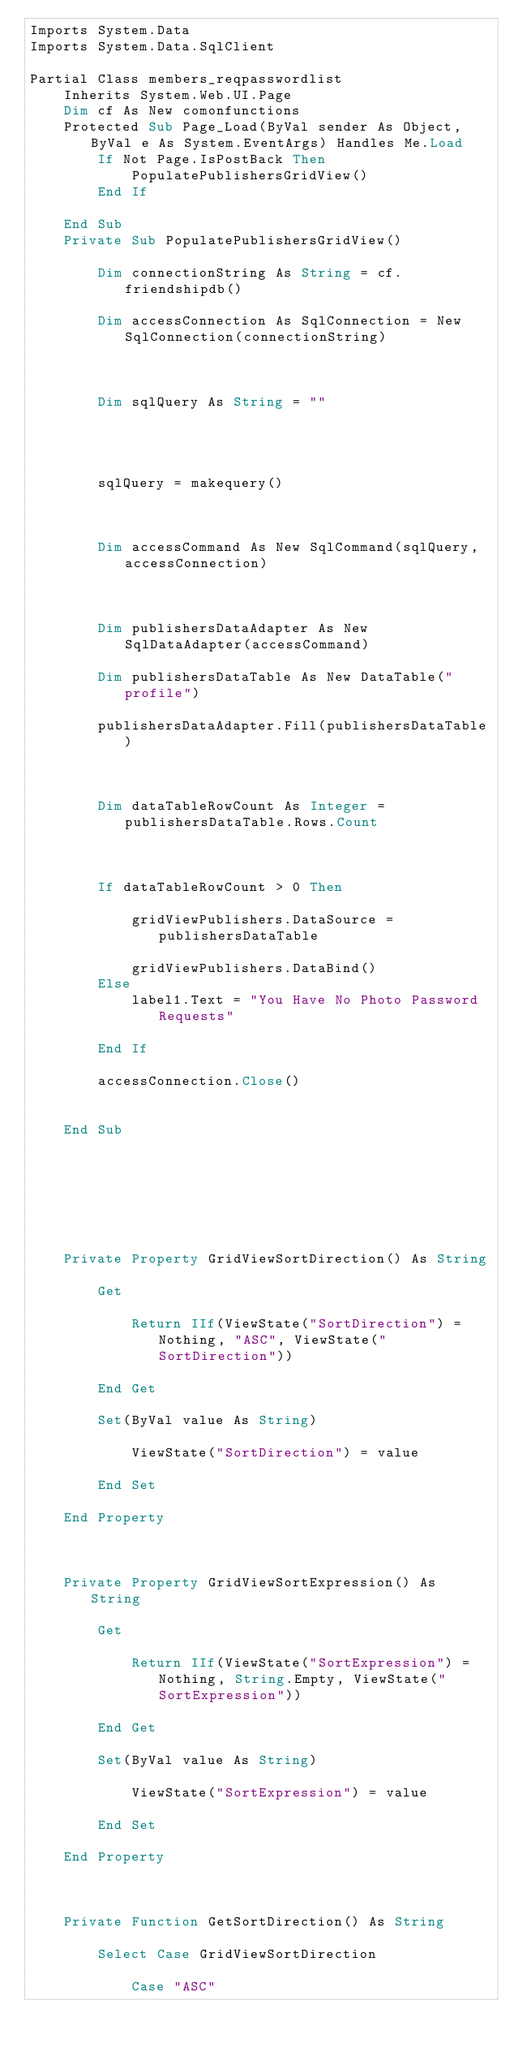<code> <loc_0><loc_0><loc_500><loc_500><_VisualBasic_>Imports System.Data
Imports System.Data.SqlClient

Partial Class members_reqpasswordlist
    Inherits System.Web.UI.Page
    Dim cf As New comonfunctions
    Protected Sub Page_Load(ByVal sender As Object, ByVal e As System.EventArgs) Handles Me.Load
        If Not Page.IsPostBack Then
            PopulatePublishersGridView()
        End If

    End Sub
    Private Sub PopulatePublishersGridView()

        Dim connectionString As String = cf.friendshipdb()

        Dim accessConnection As SqlConnection = New SqlConnection(connectionString)



        Dim sqlQuery As String = ""




        sqlQuery = makequery()



        Dim accessCommand As New SqlCommand(sqlQuery, accessConnection)



        Dim publishersDataAdapter As New SqlDataAdapter(accessCommand)

        Dim publishersDataTable As New DataTable("profile")

        publishersDataAdapter.Fill(publishersDataTable)



        Dim dataTableRowCount As Integer = publishersDataTable.Rows.Count



        If dataTableRowCount > 0 Then

            gridViewPublishers.DataSource = publishersDataTable

            gridViewPublishers.DataBind()
        Else
            label1.Text = "You Have No Photo Password Requests"

        End If

        accessConnection.Close()


    End Sub



   



    Private Property GridViewSortDirection() As String

        Get

            Return IIf(ViewState("SortDirection") = Nothing, "ASC", ViewState("SortDirection"))

        End Get

        Set(ByVal value As String)

            ViewState("SortDirection") = value

        End Set

    End Property



    Private Property GridViewSortExpression() As String

        Get

            Return IIf(ViewState("SortExpression") = Nothing, String.Empty, ViewState("SortExpression"))

        End Get

        Set(ByVal value As String)

            ViewState("SortExpression") = value

        End Set

    End Property



    Private Function GetSortDirection() As String

        Select Case GridViewSortDirection

            Case "ASC"
</code> 